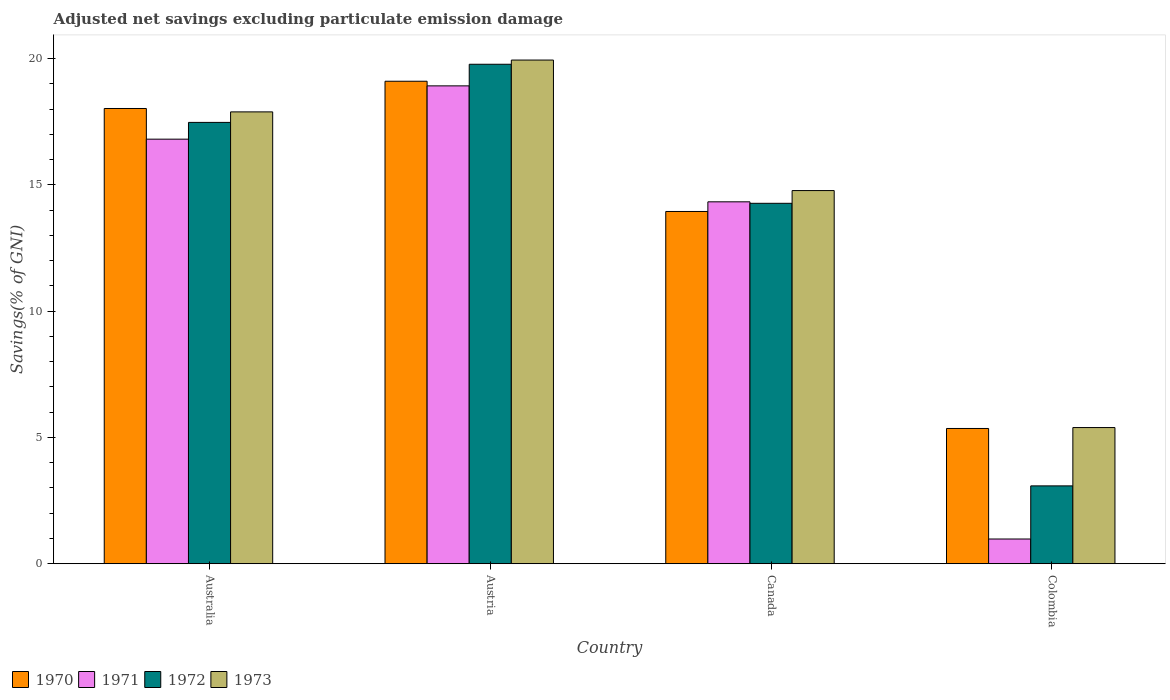How many different coloured bars are there?
Ensure brevity in your answer.  4. How many bars are there on the 3rd tick from the right?
Offer a terse response. 4. What is the label of the 1st group of bars from the left?
Your answer should be very brief. Australia. What is the adjusted net savings in 1970 in Colombia?
Your answer should be very brief. 5.36. Across all countries, what is the maximum adjusted net savings in 1972?
Your answer should be compact. 19.78. Across all countries, what is the minimum adjusted net savings in 1972?
Provide a short and direct response. 3.08. What is the total adjusted net savings in 1973 in the graph?
Keep it short and to the point. 58.01. What is the difference between the adjusted net savings in 1970 in Australia and that in Canada?
Keep it short and to the point. 4.08. What is the difference between the adjusted net savings in 1972 in Canada and the adjusted net savings in 1970 in Australia?
Your response must be concise. -3.75. What is the average adjusted net savings in 1972 per country?
Offer a very short reply. 13.65. What is the difference between the adjusted net savings of/in 1972 and adjusted net savings of/in 1973 in Colombia?
Your answer should be compact. -2.31. In how many countries, is the adjusted net savings in 1972 greater than 12 %?
Your answer should be compact. 3. What is the ratio of the adjusted net savings in 1970 in Canada to that in Colombia?
Keep it short and to the point. 2.6. What is the difference between the highest and the second highest adjusted net savings in 1973?
Your response must be concise. -2.05. What is the difference between the highest and the lowest adjusted net savings in 1972?
Ensure brevity in your answer.  16.7. Is the sum of the adjusted net savings in 1973 in Australia and Colombia greater than the maximum adjusted net savings in 1972 across all countries?
Provide a succinct answer. Yes. What does the 2nd bar from the right in Austria represents?
Your answer should be compact. 1972. Are all the bars in the graph horizontal?
Provide a succinct answer. No. How many countries are there in the graph?
Provide a succinct answer. 4. What is the difference between two consecutive major ticks on the Y-axis?
Keep it short and to the point. 5. Are the values on the major ticks of Y-axis written in scientific E-notation?
Give a very brief answer. No. Does the graph contain any zero values?
Make the answer very short. No. Where does the legend appear in the graph?
Your answer should be very brief. Bottom left. How many legend labels are there?
Your response must be concise. 4. What is the title of the graph?
Make the answer very short. Adjusted net savings excluding particulate emission damage. Does "2010" appear as one of the legend labels in the graph?
Keep it short and to the point. No. What is the label or title of the X-axis?
Offer a terse response. Country. What is the label or title of the Y-axis?
Give a very brief answer. Savings(% of GNI). What is the Savings(% of GNI) in 1970 in Australia?
Provide a short and direct response. 18.03. What is the Savings(% of GNI) in 1971 in Australia?
Make the answer very short. 16.81. What is the Savings(% of GNI) in 1972 in Australia?
Offer a terse response. 17.48. What is the Savings(% of GNI) of 1973 in Australia?
Give a very brief answer. 17.89. What is the Savings(% of GNI) of 1970 in Austria?
Offer a terse response. 19.11. What is the Savings(% of GNI) of 1971 in Austria?
Provide a succinct answer. 18.92. What is the Savings(% of GNI) in 1972 in Austria?
Offer a very short reply. 19.78. What is the Savings(% of GNI) in 1973 in Austria?
Offer a terse response. 19.94. What is the Savings(% of GNI) of 1970 in Canada?
Offer a terse response. 13.95. What is the Savings(% of GNI) of 1971 in Canada?
Provide a succinct answer. 14.33. What is the Savings(% of GNI) in 1972 in Canada?
Give a very brief answer. 14.27. What is the Savings(% of GNI) in 1973 in Canada?
Offer a terse response. 14.78. What is the Savings(% of GNI) of 1970 in Colombia?
Make the answer very short. 5.36. What is the Savings(% of GNI) of 1971 in Colombia?
Make the answer very short. 0.98. What is the Savings(% of GNI) of 1972 in Colombia?
Provide a short and direct response. 3.08. What is the Savings(% of GNI) of 1973 in Colombia?
Provide a succinct answer. 5.39. Across all countries, what is the maximum Savings(% of GNI) in 1970?
Offer a very short reply. 19.11. Across all countries, what is the maximum Savings(% of GNI) in 1971?
Your answer should be compact. 18.92. Across all countries, what is the maximum Savings(% of GNI) in 1972?
Your response must be concise. 19.78. Across all countries, what is the maximum Savings(% of GNI) of 1973?
Give a very brief answer. 19.94. Across all countries, what is the minimum Savings(% of GNI) in 1970?
Make the answer very short. 5.36. Across all countries, what is the minimum Savings(% of GNI) of 1971?
Your response must be concise. 0.98. Across all countries, what is the minimum Savings(% of GNI) in 1972?
Offer a very short reply. 3.08. Across all countries, what is the minimum Savings(% of GNI) of 1973?
Make the answer very short. 5.39. What is the total Savings(% of GNI) in 1970 in the graph?
Your response must be concise. 56.44. What is the total Savings(% of GNI) in 1971 in the graph?
Give a very brief answer. 51.04. What is the total Savings(% of GNI) of 1972 in the graph?
Your response must be concise. 54.61. What is the total Savings(% of GNI) in 1973 in the graph?
Give a very brief answer. 58.01. What is the difference between the Savings(% of GNI) in 1970 in Australia and that in Austria?
Your response must be concise. -1.08. What is the difference between the Savings(% of GNI) of 1971 in Australia and that in Austria?
Offer a terse response. -2.11. What is the difference between the Savings(% of GNI) in 1972 in Australia and that in Austria?
Your answer should be compact. -2.3. What is the difference between the Savings(% of GNI) of 1973 in Australia and that in Austria?
Provide a short and direct response. -2.05. What is the difference between the Savings(% of GNI) in 1970 in Australia and that in Canada?
Your response must be concise. 4.08. What is the difference between the Savings(% of GNI) of 1971 in Australia and that in Canada?
Keep it short and to the point. 2.48. What is the difference between the Savings(% of GNI) of 1972 in Australia and that in Canada?
Provide a succinct answer. 3.2. What is the difference between the Savings(% of GNI) of 1973 in Australia and that in Canada?
Keep it short and to the point. 3.12. What is the difference between the Savings(% of GNI) in 1970 in Australia and that in Colombia?
Your response must be concise. 12.67. What is the difference between the Savings(% of GNI) of 1971 in Australia and that in Colombia?
Your response must be concise. 15.83. What is the difference between the Savings(% of GNI) in 1972 in Australia and that in Colombia?
Provide a short and direct response. 14.39. What is the difference between the Savings(% of GNI) in 1970 in Austria and that in Canada?
Provide a short and direct response. 5.16. What is the difference between the Savings(% of GNI) of 1971 in Austria and that in Canada?
Provide a succinct answer. 4.59. What is the difference between the Savings(% of GNI) of 1972 in Austria and that in Canada?
Provide a short and direct response. 5.51. What is the difference between the Savings(% of GNI) of 1973 in Austria and that in Canada?
Your response must be concise. 5.17. What is the difference between the Savings(% of GNI) in 1970 in Austria and that in Colombia?
Your response must be concise. 13.75. What is the difference between the Savings(% of GNI) in 1971 in Austria and that in Colombia?
Provide a succinct answer. 17.94. What is the difference between the Savings(% of GNI) of 1972 in Austria and that in Colombia?
Give a very brief answer. 16.7. What is the difference between the Savings(% of GNI) in 1973 in Austria and that in Colombia?
Make the answer very short. 14.55. What is the difference between the Savings(% of GNI) in 1970 in Canada and that in Colombia?
Your response must be concise. 8.59. What is the difference between the Savings(% of GNI) in 1971 in Canada and that in Colombia?
Provide a succinct answer. 13.35. What is the difference between the Savings(% of GNI) in 1972 in Canada and that in Colombia?
Your answer should be compact. 11.19. What is the difference between the Savings(% of GNI) in 1973 in Canada and that in Colombia?
Your answer should be very brief. 9.38. What is the difference between the Savings(% of GNI) in 1970 in Australia and the Savings(% of GNI) in 1971 in Austria?
Your response must be concise. -0.9. What is the difference between the Savings(% of GNI) in 1970 in Australia and the Savings(% of GNI) in 1972 in Austria?
Give a very brief answer. -1.75. What is the difference between the Savings(% of GNI) in 1970 in Australia and the Savings(% of GNI) in 1973 in Austria?
Your response must be concise. -1.92. What is the difference between the Savings(% of GNI) of 1971 in Australia and the Savings(% of GNI) of 1972 in Austria?
Offer a terse response. -2.97. What is the difference between the Savings(% of GNI) of 1971 in Australia and the Savings(% of GNI) of 1973 in Austria?
Ensure brevity in your answer.  -3.13. What is the difference between the Savings(% of GNI) in 1972 in Australia and the Savings(% of GNI) in 1973 in Austria?
Keep it short and to the point. -2.47. What is the difference between the Savings(% of GNI) of 1970 in Australia and the Savings(% of GNI) of 1971 in Canada?
Ensure brevity in your answer.  3.7. What is the difference between the Savings(% of GNI) in 1970 in Australia and the Savings(% of GNI) in 1972 in Canada?
Keep it short and to the point. 3.75. What is the difference between the Savings(% of GNI) of 1970 in Australia and the Savings(% of GNI) of 1973 in Canada?
Provide a short and direct response. 3.25. What is the difference between the Savings(% of GNI) of 1971 in Australia and the Savings(% of GNI) of 1972 in Canada?
Your answer should be compact. 2.54. What is the difference between the Savings(% of GNI) in 1971 in Australia and the Savings(% of GNI) in 1973 in Canada?
Your answer should be compact. 2.04. What is the difference between the Savings(% of GNI) in 1972 in Australia and the Savings(% of GNI) in 1973 in Canada?
Your answer should be compact. 2.7. What is the difference between the Savings(% of GNI) in 1970 in Australia and the Savings(% of GNI) in 1971 in Colombia?
Provide a succinct answer. 17.05. What is the difference between the Savings(% of GNI) in 1970 in Australia and the Savings(% of GNI) in 1972 in Colombia?
Provide a short and direct response. 14.94. What is the difference between the Savings(% of GNI) of 1970 in Australia and the Savings(% of GNI) of 1973 in Colombia?
Give a very brief answer. 12.63. What is the difference between the Savings(% of GNI) of 1971 in Australia and the Savings(% of GNI) of 1972 in Colombia?
Provide a succinct answer. 13.73. What is the difference between the Savings(% of GNI) of 1971 in Australia and the Savings(% of GNI) of 1973 in Colombia?
Provide a short and direct response. 11.42. What is the difference between the Savings(% of GNI) in 1972 in Australia and the Savings(% of GNI) in 1973 in Colombia?
Your response must be concise. 12.08. What is the difference between the Savings(% of GNI) in 1970 in Austria and the Savings(% of GNI) in 1971 in Canada?
Offer a terse response. 4.77. What is the difference between the Savings(% of GNI) of 1970 in Austria and the Savings(% of GNI) of 1972 in Canada?
Your answer should be very brief. 4.83. What is the difference between the Savings(% of GNI) in 1970 in Austria and the Savings(% of GNI) in 1973 in Canada?
Provide a succinct answer. 4.33. What is the difference between the Savings(% of GNI) in 1971 in Austria and the Savings(% of GNI) in 1972 in Canada?
Keep it short and to the point. 4.65. What is the difference between the Savings(% of GNI) in 1971 in Austria and the Savings(% of GNI) in 1973 in Canada?
Ensure brevity in your answer.  4.15. What is the difference between the Savings(% of GNI) in 1972 in Austria and the Savings(% of GNI) in 1973 in Canada?
Ensure brevity in your answer.  5. What is the difference between the Savings(% of GNI) in 1970 in Austria and the Savings(% of GNI) in 1971 in Colombia?
Your answer should be compact. 18.13. What is the difference between the Savings(% of GNI) of 1970 in Austria and the Savings(% of GNI) of 1972 in Colombia?
Provide a succinct answer. 16.02. What is the difference between the Savings(% of GNI) in 1970 in Austria and the Savings(% of GNI) in 1973 in Colombia?
Your response must be concise. 13.71. What is the difference between the Savings(% of GNI) of 1971 in Austria and the Savings(% of GNI) of 1972 in Colombia?
Your answer should be compact. 15.84. What is the difference between the Savings(% of GNI) of 1971 in Austria and the Savings(% of GNI) of 1973 in Colombia?
Provide a short and direct response. 13.53. What is the difference between the Savings(% of GNI) of 1972 in Austria and the Savings(% of GNI) of 1973 in Colombia?
Your response must be concise. 14.39. What is the difference between the Savings(% of GNI) in 1970 in Canada and the Savings(% of GNI) in 1971 in Colombia?
Provide a succinct answer. 12.97. What is the difference between the Savings(% of GNI) of 1970 in Canada and the Savings(% of GNI) of 1972 in Colombia?
Ensure brevity in your answer.  10.87. What is the difference between the Savings(% of GNI) in 1970 in Canada and the Savings(% of GNI) in 1973 in Colombia?
Provide a succinct answer. 8.56. What is the difference between the Savings(% of GNI) in 1971 in Canada and the Savings(% of GNI) in 1972 in Colombia?
Offer a terse response. 11.25. What is the difference between the Savings(% of GNI) in 1971 in Canada and the Savings(% of GNI) in 1973 in Colombia?
Offer a very short reply. 8.94. What is the difference between the Savings(% of GNI) in 1972 in Canada and the Savings(% of GNI) in 1973 in Colombia?
Your answer should be compact. 8.88. What is the average Savings(% of GNI) of 1970 per country?
Give a very brief answer. 14.11. What is the average Savings(% of GNI) in 1971 per country?
Offer a very short reply. 12.76. What is the average Savings(% of GNI) of 1972 per country?
Your response must be concise. 13.65. What is the average Savings(% of GNI) in 1973 per country?
Provide a short and direct response. 14.5. What is the difference between the Savings(% of GNI) in 1970 and Savings(% of GNI) in 1971 in Australia?
Give a very brief answer. 1.21. What is the difference between the Savings(% of GNI) in 1970 and Savings(% of GNI) in 1972 in Australia?
Offer a terse response. 0.55. What is the difference between the Savings(% of GNI) in 1970 and Savings(% of GNI) in 1973 in Australia?
Make the answer very short. 0.13. What is the difference between the Savings(% of GNI) of 1971 and Savings(% of GNI) of 1972 in Australia?
Offer a terse response. -0.66. What is the difference between the Savings(% of GNI) of 1971 and Savings(% of GNI) of 1973 in Australia?
Your answer should be compact. -1.08. What is the difference between the Savings(% of GNI) in 1972 and Savings(% of GNI) in 1973 in Australia?
Provide a succinct answer. -0.42. What is the difference between the Savings(% of GNI) of 1970 and Savings(% of GNI) of 1971 in Austria?
Your answer should be very brief. 0.18. What is the difference between the Savings(% of GNI) of 1970 and Savings(% of GNI) of 1972 in Austria?
Give a very brief answer. -0.67. What is the difference between the Savings(% of GNI) of 1970 and Savings(% of GNI) of 1973 in Austria?
Offer a terse response. -0.84. What is the difference between the Savings(% of GNI) of 1971 and Savings(% of GNI) of 1972 in Austria?
Provide a short and direct response. -0.86. What is the difference between the Savings(% of GNI) in 1971 and Savings(% of GNI) in 1973 in Austria?
Offer a terse response. -1.02. What is the difference between the Savings(% of GNI) of 1972 and Savings(% of GNI) of 1973 in Austria?
Make the answer very short. -0.17. What is the difference between the Savings(% of GNI) of 1970 and Savings(% of GNI) of 1971 in Canada?
Your answer should be very brief. -0.38. What is the difference between the Savings(% of GNI) in 1970 and Savings(% of GNI) in 1972 in Canada?
Give a very brief answer. -0.32. What is the difference between the Savings(% of GNI) in 1970 and Savings(% of GNI) in 1973 in Canada?
Give a very brief answer. -0.83. What is the difference between the Savings(% of GNI) of 1971 and Savings(% of GNI) of 1972 in Canada?
Make the answer very short. 0.06. What is the difference between the Savings(% of GNI) in 1971 and Savings(% of GNI) in 1973 in Canada?
Your response must be concise. -0.45. What is the difference between the Savings(% of GNI) in 1972 and Savings(% of GNI) in 1973 in Canada?
Offer a terse response. -0.5. What is the difference between the Savings(% of GNI) in 1970 and Savings(% of GNI) in 1971 in Colombia?
Offer a terse response. 4.38. What is the difference between the Savings(% of GNI) of 1970 and Savings(% of GNI) of 1972 in Colombia?
Your answer should be very brief. 2.27. What is the difference between the Savings(% of GNI) in 1970 and Savings(% of GNI) in 1973 in Colombia?
Give a very brief answer. -0.04. What is the difference between the Savings(% of GNI) in 1971 and Savings(% of GNI) in 1972 in Colombia?
Ensure brevity in your answer.  -2.1. What is the difference between the Savings(% of GNI) in 1971 and Savings(% of GNI) in 1973 in Colombia?
Provide a succinct answer. -4.41. What is the difference between the Savings(% of GNI) of 1972 and Savings(% of GNI) of 1973 in Colombia?
Give a very brief answer. -2.31. What is the ratio of the Savings(% of GNI) of 1970 in Australia to that in Austria?
Make the answer very short. 0.94. What is the ratio of the Savings(% of GNI) of 1971 in Australia to that in Austria?
Your answer should be compact. 0.89. What is the ratio of the Savings(% of GNI) in 1972 in Australia to that in Austria?
Provide a short and direct response. 0.88. What is the ratio of the Savings(% of GNI) of 1973 in Australia to that in Austria?
Your answer should be compact. 0.9. What is the ratio of the Savings(% of GNI) in 1970 in Australia to that in Canada?
Ensure brevity in your answer.  1.29. What is the ratio of the Savings(% of GNI) in 1971 in Australia to that in Canada?
Provide a short and direct response. 1.17. What is the ratio of the Savings(% of GNI) in 1972 in Australia to that in Canada?
Your answer should be compact. 1.22. What is the ratio of the Savings(% of GNI) of 1973 in Australia to that in Canada?
Keep it short and to the point. 1.21. What is the ratio of the Savings(% of GNI) of 1970 in Australia to that in Colombia?
Provide a succinct answer. 3.37. What is the ratio of the Savings(% of GNI) of 1971 in Australia to that in Colombia?
Your response must be concise. 17.17. What is the ratio of the Savings(% of GNI) of 1972 in Australia to that in Colombia?
Your response must be concise. 5.67. What is the ratio of the Savings(% of GNI) in 1973 in Australia to that in Colombia?
Offer a very short reply. 3.32. What is the ratio of the Savings(% of GNI) in 1970 in Austria to that in Canada?
Provide a short and direct response. 1.37. What is the ratio of the Savings(% of GNI) of 1971 in Austria to that in Canada?
Your answer should be very brief. 1.32. What is the ratio of the Savings(% of GNI) in 1972 in Austria to that in Canada?
Your response must be concise. 1.39. What is the ratio of the Savings(% of GNI) of 1973 in Austria to that in Canada?
Provide a short and direct response. 1.35. What is the ratio of the Savings(% of GNI) of 1970 in Austria to that in Colombia?
Make the answer very short. 3.57. What is the ratio of the Savings(% of GNI) of 1971 in Austria to that in Colombia?
Make the answer very short. 19.32. What is the ratio of the Savings(% of GNI) in 1972 in Austria to that in Colombia?
Provide a short and direct response. 6.42. What is the ratio of the Savings(% of GNI) in 1973 in Austria to that in Colombia?
Keep it short and to the point. 3.7. What is the ratio of the Savings(% of GNI) in 1970 in Canada to that in Colombia?
Provide a succinct answer. 2.6. What is the ratio of the Savings(% of GNI) in 1971 in Canada to that in Colombia?
Keep it short and to the point. 14.64. What is the ratio of the Savings(% of GNI) in 1972 in Canada to that in Colombia?
Provide a short and direct response. 4.63. What is the ratio of the Savings(% of GNI) in 1973 in Canada to that in Colombia?
Offer a very short reply. 2.74. What is the difference between the highest and the second highest Savings(% of GNI) in 1970?
Keep it short and to the point. 1.08. What is the difference between the highest and the second highest Savings(% of GNI) of 1971?
Your response must be concise. 2.11. What is the difference between the highest and the second highest Savings(% of GNI) in 1972?
Offer a terse response. 2.3. What is the difference between the highest and the second highest Savings(% of GNI) of 1973?
Provide a short and direct response. 2.05. What is the difference between the highest and the lowest Savings(% of GNI) of 1970?
Keep it short and to the point. 13.75. What is the difference between the highest and the lowest Savings(% of GNI) in 1971?
Ensure brevity in your answer.  17.94. What is the difference between the highest and the lowest Savings(% of GNI) in 1972?
Keep it short and to the point. 16.7. What is the difference between the highest and the lowest Savings(% of GNI) in 1973?
Your answer should be very brief. 14.55. 